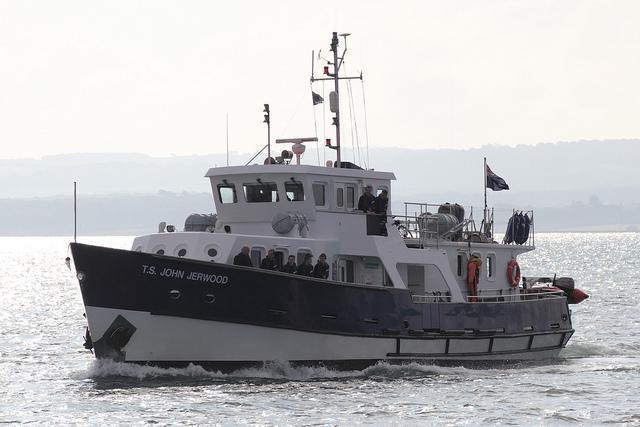Why is there writing on the boat?
Indicate the correct response and explain using: 'Answer: answer
Rationale: rationale.'
Options: Fleet number, sales ad, graffiti, boat name. Answer: boat name.
Rationale: It is identification. 